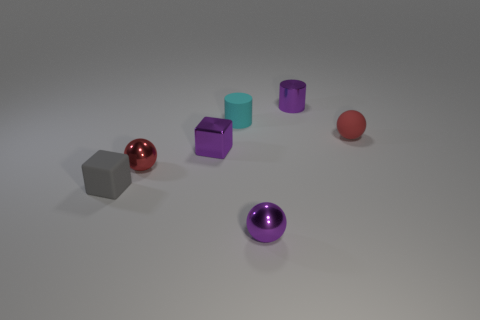Are there any small gray objects made of the same material as the small cyan object?
Provide a succinct answer. Yes. What number of matte objects are there?
Offer a terse response. 3. There is a tiny sphere right of the tiny sphere that is in front of the small gray rubber block; what is its material?
Offer a very short reply. Rubber. What is the color of the small ball that is made of the same material as the tiny gray thing?
Your response must be concise. Red. What shape is the tiny shiny object that is the same color as the rubber ball?
Offer a terse response. Sphere. How many spheres are small red shiny objects or small purple metallic objects?
Ensure brevity in your answer.  2. Does the small ball that is to the right of the tiny purple cylinder have the same material as the purple cylinder?
Provide a succinct answer. No. How many other things are there of the same size as the red matte object?
Keep it short and to the point. 6. How many large things are purple spheres or blue metal cubes?
Your response must be concise. 0. Is the color of the small metallic cube the same as the matte ball?
Your answer should be compact. No. 